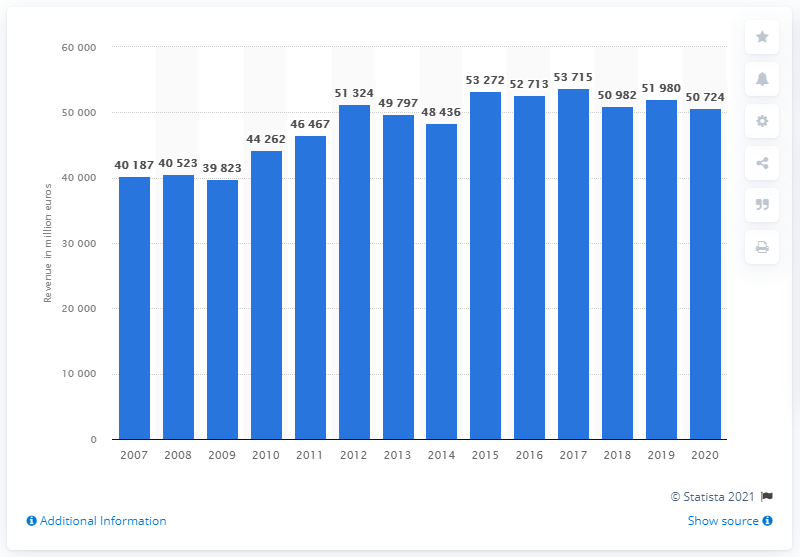Draw attention to some important aspects in this diagram. In 2020, the global revenue of Unilever Group was approximately 507,240. 